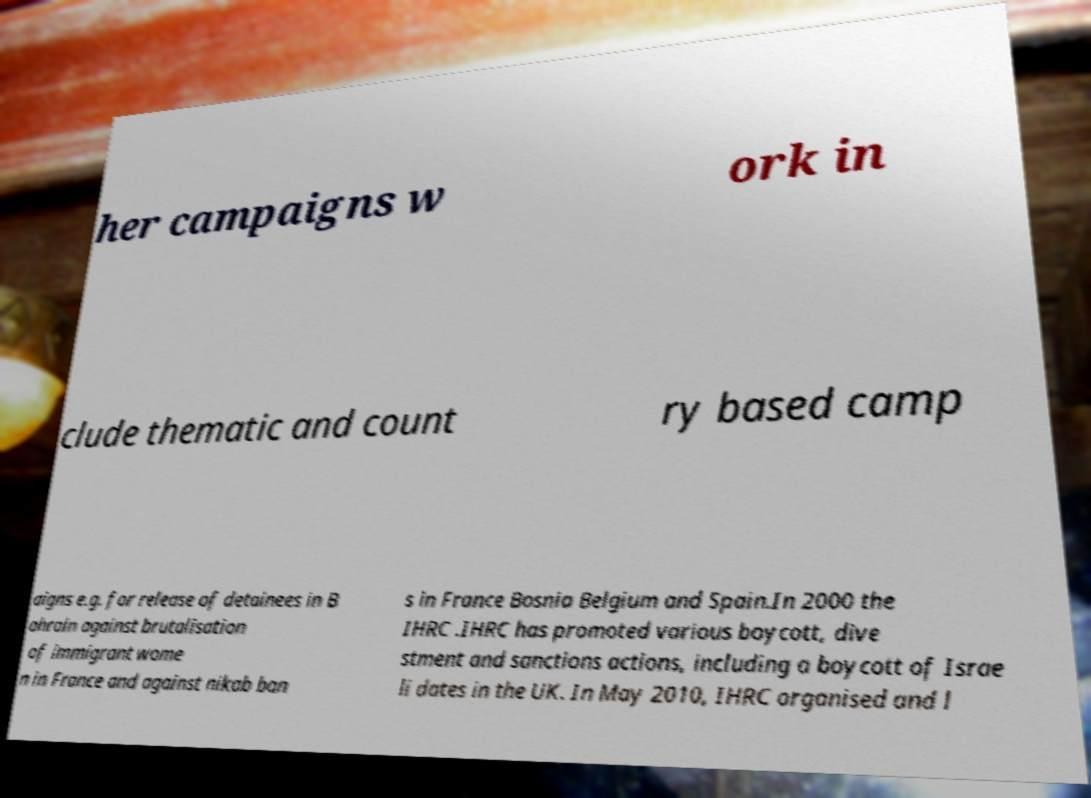Could you assist in decoding the text presented in this image and type it out clearly? her campaigns w ork in clude thematic and count ry based camp aigns e.g. for release of detainees in B ahrain against brutalisation of immigrant wome n in France and against nikab ban s in France Bosnia Belgium and Spain.In 2000 the IHRC .IHRC has promoted various boycott, dive stment and sanctions actions, including a boycott of Israe li dates in the UK. In May 2010, IHRC organised and l 